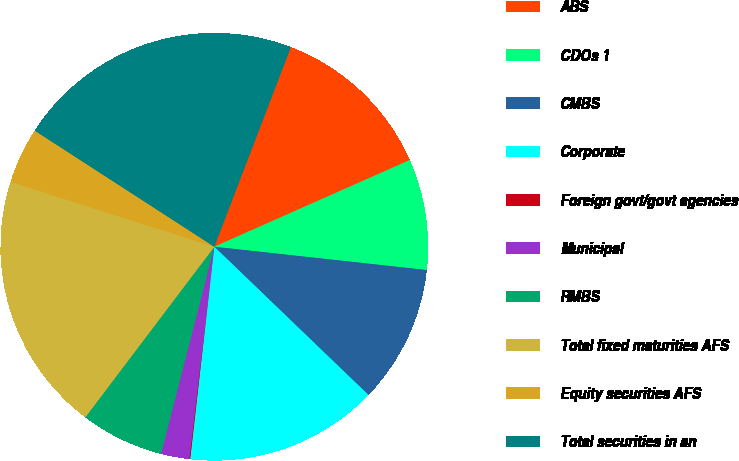Convert chart. <chart><loc_0><loc_0><loc_500><loc_500><pie_chart><fcel>ABS<fcel>CDOs 1<fcel>CMBS<fcel>Corporate<fcel>Foreign govt/govt agencies<fcel>Municipal<fcel>RMBS<fcel>Total fixed maturities AFS<fcel>Equity securities AFS<fcel>Total securities in an<nl><fcel>12.53%<fcel>8.38%<fcel>10.45%<fcel>14.61%<fcel>0.07%<fcel>2.14%<fcel>6.3%<fcel>19.61%<fcel>4.22%<fcel>21.69%<nl></chart> 